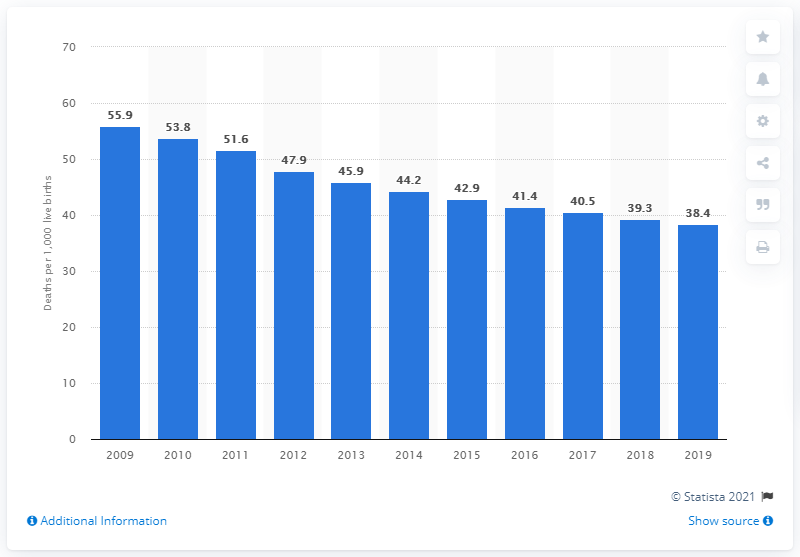Highlight a few significant elements in this photo. The infant mortality rate in Zimbabwe in 2019 was 38.4 per 1,000 live births. 